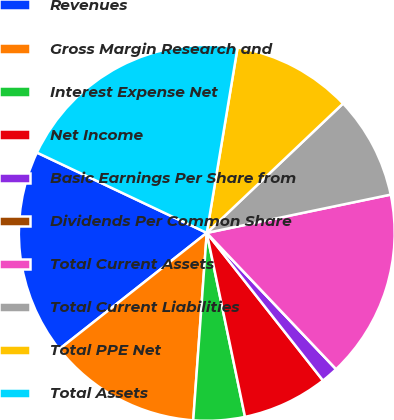<chart> <loc_0><loc_0><loc_500><loc_500><pie_chart><fcel>Revenues<fcel>Gross Margin Research and<fcel>Interest Expense Net<fcel>Net Income<fcel>Basic Earnings Per Share from<fcel>Dividends Per Common Share<fcel>Total Current Assets<fcel>Total Current Liabilities<fcel>Total PPE Net<fcel>Total Assets<nl><fcel>17.65%<fcel>13.23%<fcel>4.41%<fcel>7.35%<fcel>1.47%<fcel>0.0%<fcel>16.18%<fcel>8.82%<fcel>10.29%<fcel>20.59%<nl></chart> 